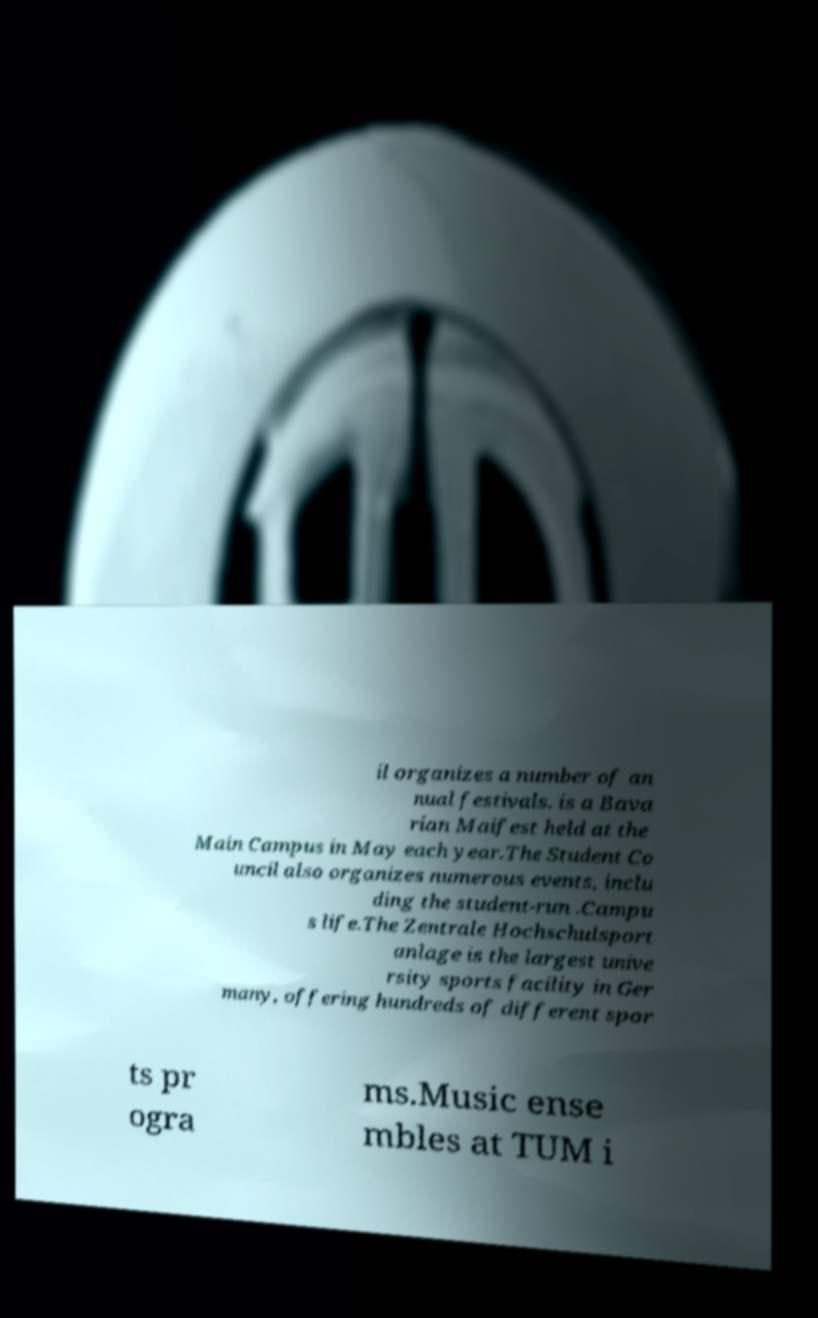Please identify and transcribe the text found in this image. il organizes a number of an nual festivals. is a Bava rian Maifest held at the Main Campus in May each year.The Student Co uncil also organizes numerous events, inclu ding the student-run .Campu s life.The Zentrale Hochschulsport anlage is the largest unive rsity sports facility in Ger many, offering hundreds of different spor ts pr ogra ms.Music ense mbles at TUM i 